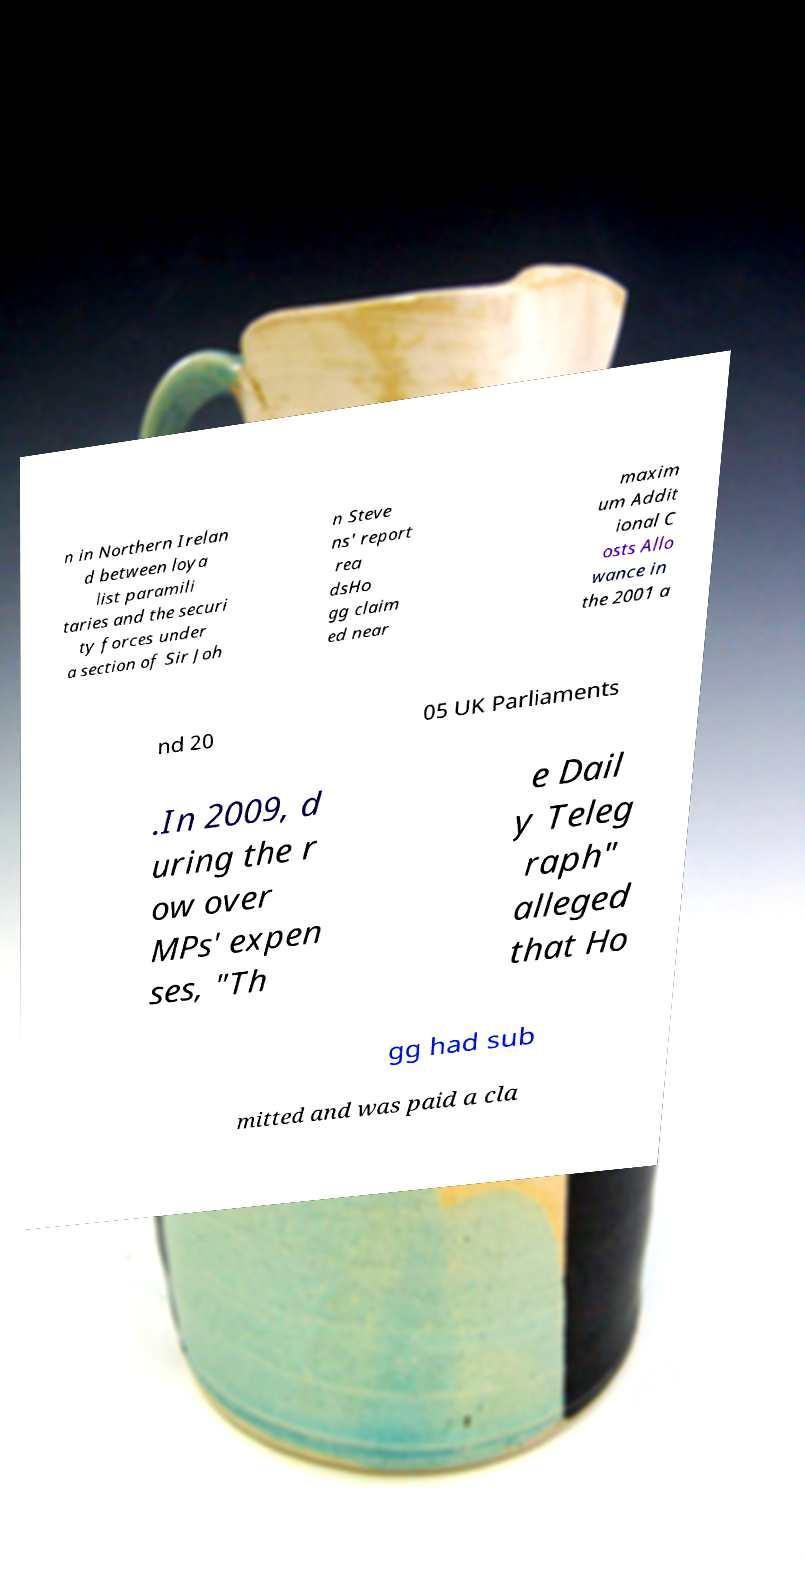What messages or text are displayed in this image? I need them in a readable, typed format. n in Northern Irelan d between loya list paramili taries and the securi ty forces under a section of Sir Joh n Steve ns' report rea dsHo gg claim ed near maxim um Addit ional C osts Allo wance in the 2001 a nd 20 05 UK Parliaments .In 2009, d uring the r ow over MPs' expen ses, "Th e Dail y Teleg raph" alleged that Ho gg had sub mitted and was paid a cla 